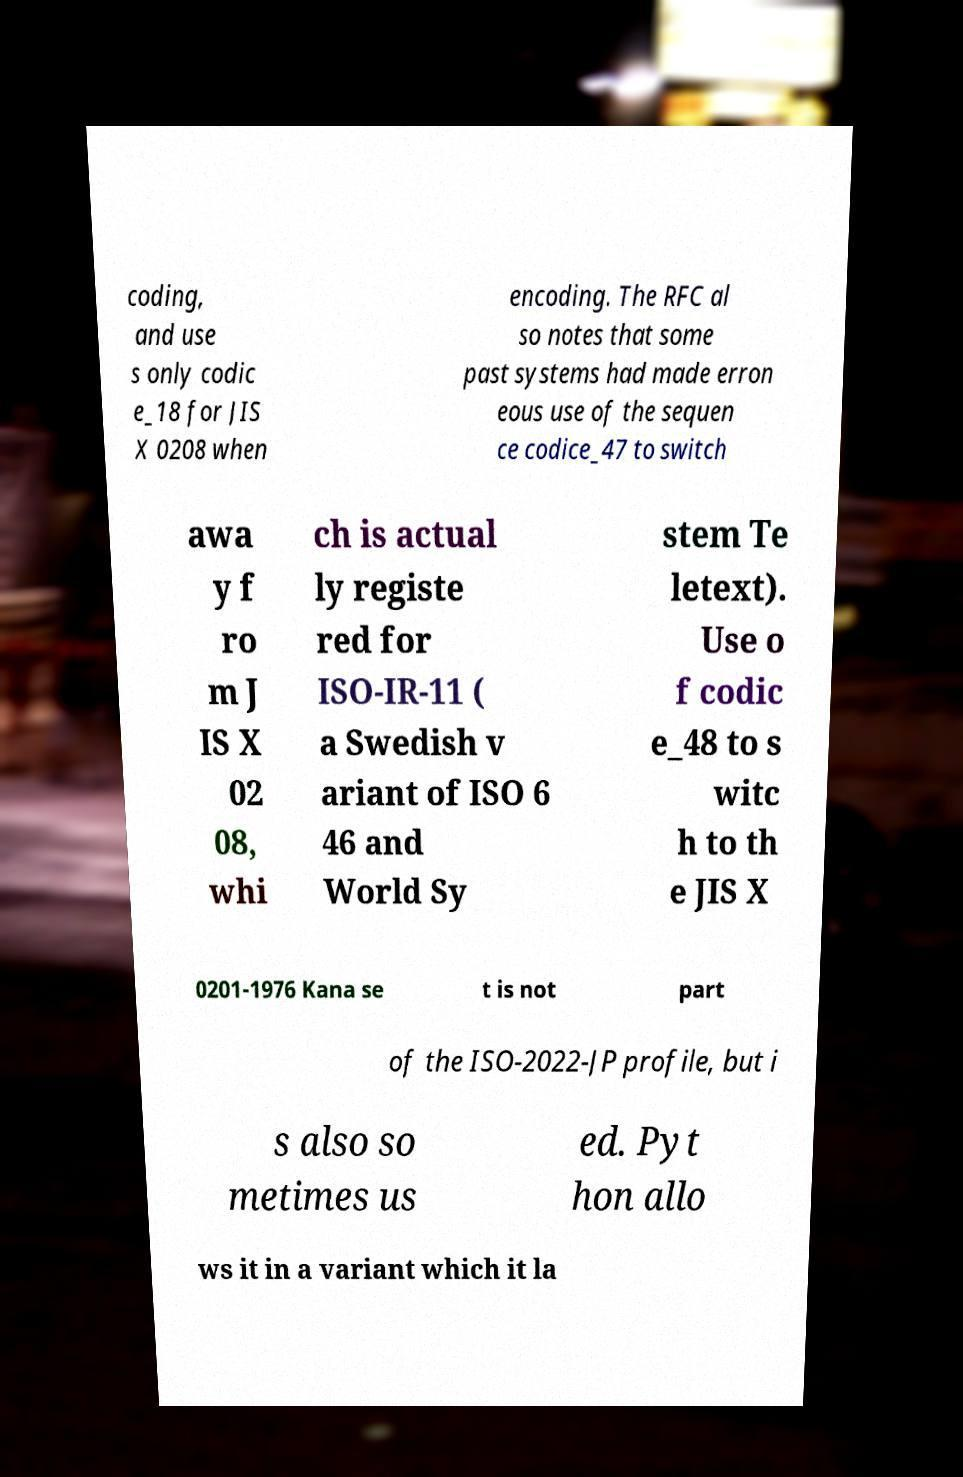There's text embedded in this image that I need extracted. Can you transcribe it verbatim? coding, and use s only codic e_18 for JIS X 0208 when encoding. The RFC al so notes that some past systems had made erron eous use of the sequen ce codice_47 to switch awa y f ro m J IS X 02 08, whi ch is actual ly registe red for ISO-IR-11 ( a Swedish v ariant of ISO 6 46 and World Sy stem Te letext). Use o f codic e_48 to s witc h to th e JIS X 0201-1976 Kana se t is not part of the ISO-2022-JP profile, but i s also so metimes us ed. Pyt hon allo ws it in a variant which it la 